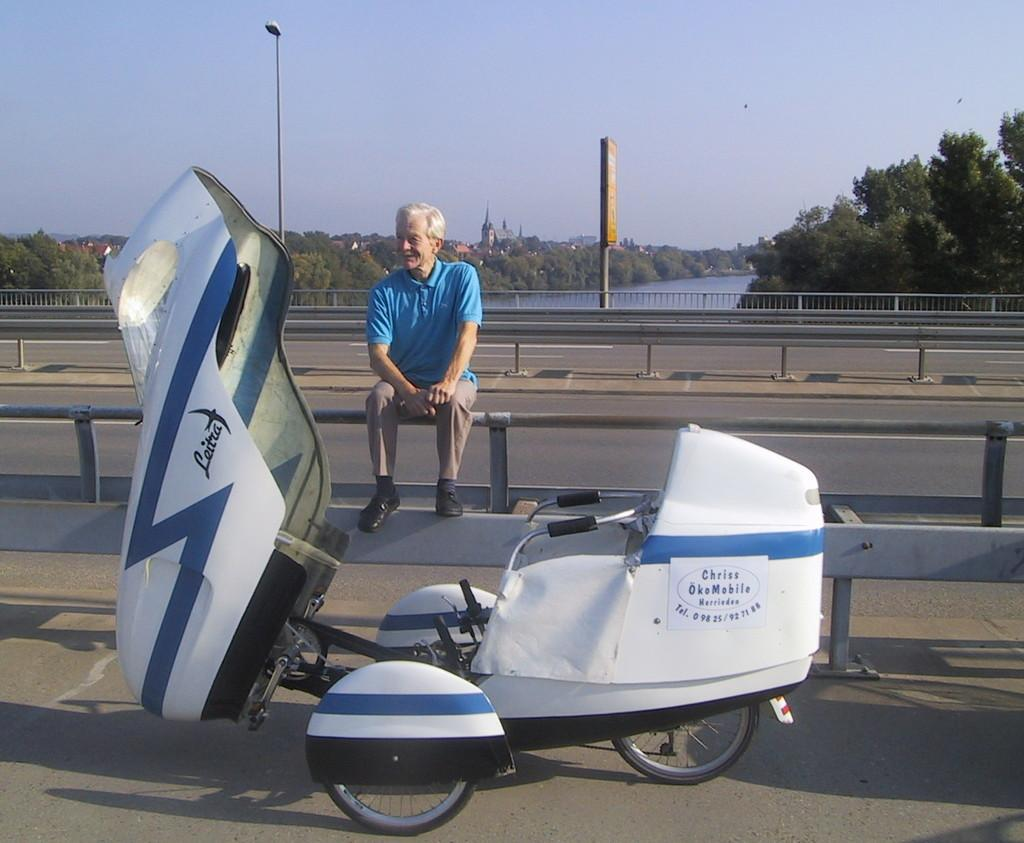Provide a one-sentence caption for the provided image. The Scooter has an ad for Chriss OkeMobile on the side. 